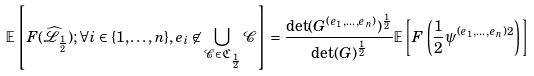<formula> <loc_0><loc_0><loc_500><loc_500>\mathbb { E } \left [ F ( \widehat { \mathcal { L } } _ { \frac { 1 } { 2 } } ) ; \forall i \in \{ 1 , \dots , n \} , e _ { i } \not \in \bigcup _ { \mathcal { C } \in \mathfrak { C } _ { \frac { 1 } { 2 } } } \mathcal { C } \right ] = \frac { \det ( G ^ { ( e _ { 1 } , \dots , e _ { n } ) } ) ^ { \frac { 1 } { 2 } } } { \det ( G ) ^ { \frac { 1 } { 2 } } } \mathbb { E } \left [ F \left ( \frac { 1 } { 2 } \psi ^ { ( e _ { 1 } , \dots , e _ { n } ) 2 } \right ) \right ]</formula> 